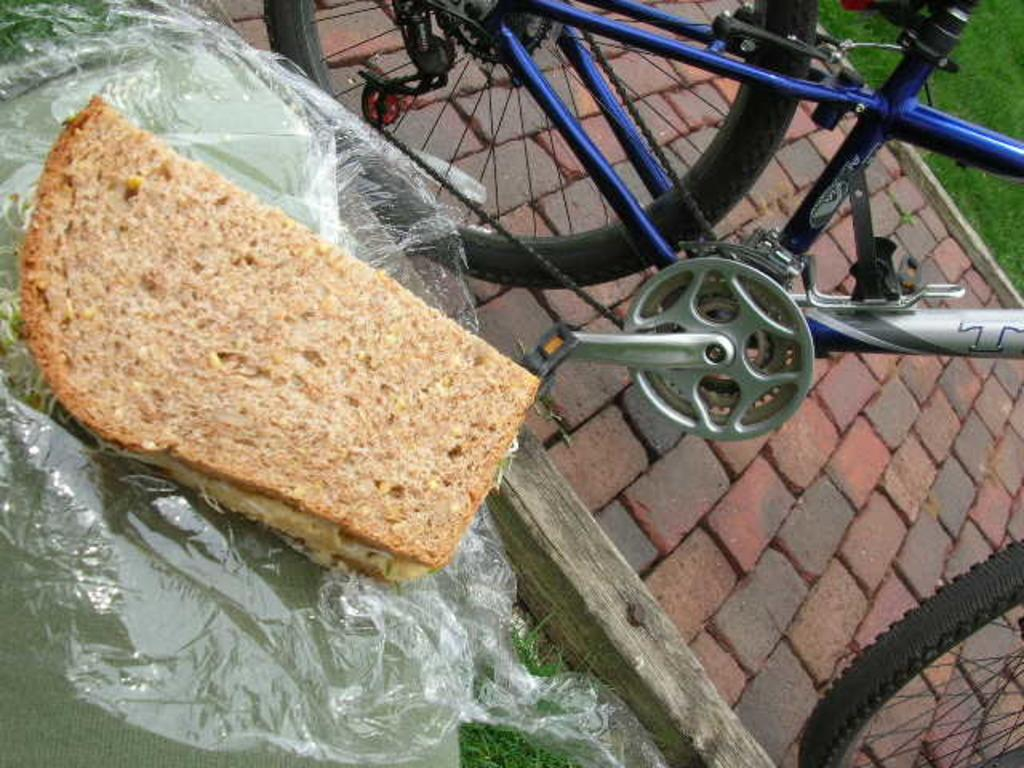What type of food item can be seen in the image? There is a food item that resembles a sandwich in the image. How is the food item being presented? The food item is on a cover. Where is the covered food item located? The cover is on a table. What other object can be seen near the table? There is a bicycle on the floor beside the table. What can be seen in the background of the image? Grass is visible in the background of the image. What type of bridge can be seen in the image? There is no bridge present in the image. How many umbrellas are visible in the image? There are no umbrellas visible in the image. 